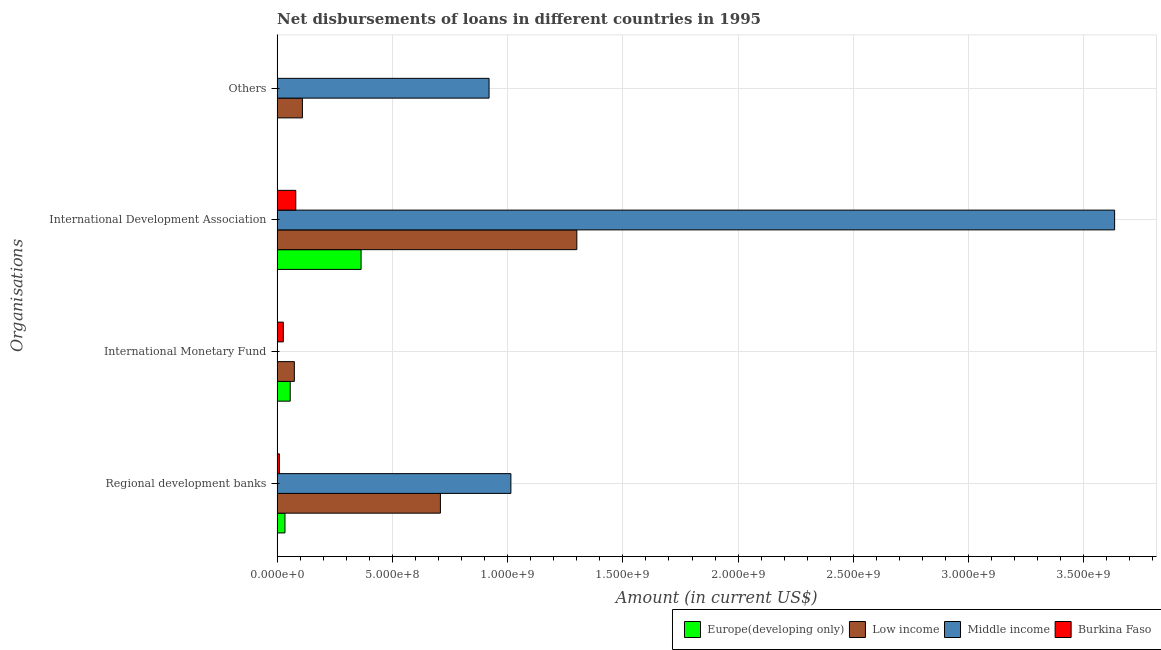How many different coloured bars are there?
Your answer should be very brief. 4. How many groups of bars are there?
Provide a succinct answer. 4. How many bars are there on the 1st tick from the top?
Your answer should be very brief. 2. How many bars are there on the 2nd tick from the bottom?
Provide a short and direct response. 3. What is the label of the 1st group of bars from the top?
Your answer should be very brief. Others. What is the amount of loan disimbursed by regional development banks in Europe(developing only)?
Your answer should be compact. 3.40e+07. Across all countries, what is the maximum amount of loan disimbursed by other organisations?
Keep it short and to the point. 9.20e+08. Across all countries, what is the minimum amount of loan disimbursed by other organisations?
Offer a terse response. 0. What is the total amount of loan disimbursed by international monetary fund in the graph?
Your response must be concise. 1.58e+08. What is the difference between the amount of loan disimbursed by international monetary fund in Europe(developing only) and that in Low income?
Your response must be concise. -1.80e+07. What is the difference between the amount of loan disimbursed by other organisations in Low income and the amount of loan disimbursed by regional development banks in Europe(developing only)?
Your answer should be compact. 7.57e+07. What is the average amount of loan disimbursed by regional development banks per country?
Your response must be concise. 4.42e+08. What is the difference between the amount of loan disimbursed by international development association and amount of loan disimbursed by other organisations in Low income?
Provide a succinct answer. 1.19e+09. In how many countries, is the amount of loan disimbursed by international monetary fund greater than 3200000000 US$?
Provide a short and direct response. 0. What is the ratio of the amount of loan disimbursed by regional development banks in Low income to that in Europe(developing only)?
Offer a terse response. 20.84. Is the amount of loan disimbursed by regional development banks in Burkina Faso less than that in Middle income?
Keep it short and to the point. Yes. Is the difference between the amount of loan disimbursed by regional development banks in Europe(developing only) and Low income greater than the difference between the amount of loan disimbursed by international development association in Europe(developing only) and Low income?
Offer a terse response. Yes. What is the difference between the highest and the second highest amount of loan disimbursed by international development association?
Keep it short and to the point. 2.33e+09. What is the difference between the highest and the lowest amount of loan disimbursed by regional development banks?
Ensure brevity in your answer.  1.00e+09. Is the sum of the amount of loan disimbursed by regional development banks in Burkina Faso and Europe(developing only) greater than the maximum amount of loan disimbursed by international development association across all countries?
Keep it short and to the point. No. Is it the case that in every country, the sum of the amount of loan disimbursed by regional development banks and amount of loan disimbursed by international monetary fund is greater than the amount of loan disimbursed by international development association?
Make the answer very short. No. How many bars are there?
Provide a short and direct response. 13. How many countries are there in the graph?
Provide a short and direct response. 4. What is the difference between two consecutive major ticks on the X-axis?
Provide a short and direct response. 5.00e+08. Does the graph contain any zero values?
Your answer should be very brief. Yes. How many legend labels are there?
Provide a succinct answer. 4. What is the title of the graph?
Make the answer very short. Net disbursements of loans in different countries in 1995. What is the label or title of the Y-axis?
Provide a succinct answer. Organisations. What is the Amount (in current US$) of Europe(developing only) in Regional development banks?
Your answer should be very brief. 3.40e+07. What is the Amount (in current US$) in Low income in Regional development banks?
Your response must be concise. 7.08e+08. What is the Amount (in current US$) of Middle income in Regional development banks?
Make the answer very short. 1.01e+09. What is the Amount (in current US$) in Burkina Faso in Regional development banks?
Offer a terse response. 9.90e+06. What is the Amount (in current US$) in Europe(developing only) in International Monetary Fund?
Provide a succinct answer. 5.67e+07. What is the Amount (in current US$) of Low income in International Monetary Fund?
Ensure brevity in your answer.  7.47e+07. What is the Amount (in current US$) in Burkina Faso in International Monetary Fund?
Your answer should be compact. 2.68e+07. What is the Amount (in current US$) of Europe(developing only) in International Development Association?
Your answer should be very brief. 3.64e+08. What is the Amount (in current US$) of Low income in International Development Association?
Keep it short and to the point. 1.30e+09. What is the Amount (in current US$) of Middle income in International Development Association?
Your answer should be very brief. 3.63e+09. What is the Amount (in current US$) of Burkina Faso in International Development Association?
Provide a short and direct response. 8.10e+07. What is the Amount (in current US$) in Europe(developing only) in Others?
Provide a succinct answer. 0. What is the Amount (in current US$) in Low income in Others?
Provide a succinct answer. 1.10e+08. What is the Amount (in current US$) in Middle income in Others?
Ensure brevity in your answer.  9.20e+08. Across all Organisations, what is the maximum Amount (in current US$) of Europe(developing only)?
Offer a very short reply. 3.64e+08. Across all Organisations, what is the maximum Amount (in current US$) in Low income?
Your answer should be compact. 1.30e+09. Across all Organisations, what is the maximum Amount (in current US$) in Middle income?
Provide a short and direct response. 3.63e+09. Across all Organisations, what is the maximum Amount (in current US$) in Burkina Faso?
Provide a short and direct response. 8.10e+07. Across all Organisations, what is the minimum Amount (in current US$) of Europe(developing only)?
Offer a terse response. 0. Across all Organisations, what is the minimum Amount (in current US$) in Low income?
Your answer should be compact. 7.47e+07. What is the total Amount (in current US$) of Europe(developing only) in the graph?
Your answer should be compact. 4.55e+08. What is the total Amount (in current US$) of Low income in the graph?
Provide a short and direct response. 2.19e+09. What is the total Amount (in current US$) of Middle income in the graph?
Make the answer very short. 5.57e+09. What is the total Amount (in current US$) in Burkina Faso in the graph?
Offer a very short reply. 1.18e+08. What is the difference between the Amount (in current US$) in Europe(developing only) in Regional development banks and that in International Monetary Fund?
Give a very brief answer. -2.27e+07. What is the difference between the Amount (in current US$) of Low income in Regional development banks and that in International Monetary Fund?
Provide a succinct answer. 6.34e+08. What is the difference between the Amount (in current US$) in Burkina Faso in Regional development banks and that in International Monetary Fund?
Provide a succinct answer. -1.69e+07. What is the difference between the Amount (in current US$) of Europe(developing only) in Regional development banks and that in International Development Association?
Ensure brevity in your answer.  -3.30e+08. What is the difference between the Amount (in current US$) in Low income in Regional development banks and that in International Development Association?
Your response must be concise. -5.92e+08. What is the difference between the Amount (in current US$) of Middle income in Regional development banks and that in International Development Association?
Your answer should be very brief. -2.62e+09. What is the difference between the Amount (in current US$) of Burkina Faso in Regional development banks and that in International Development Association?
Make the answer very short. -7.11e+07. What is the difference between the Amount (in current US$) of Low income in Regional development banks and that in Others?
Provide a short and direct response. 5.99e+08. What is the difference between the Amount (in current US$) of Middle income in Regional development banks and that in Others?
Your answer should be compact. 9.47e+07. What is the difference between the Amount (in current US$) of Europe(developing only) in International Monetary Fund and that in International Development Association?
Keep it short and to the point. -3.08e+08. What is the difference between the Amount (in current US$) of Low income in International Monetary Fund and that in International Development Association?
Your answer should be very brief. -1.23e+09. What is the difference between the Amount (in current US$) of Burkina Faso in International Monetary Fund and that in International Development Association?
Provide a short and direct response. -5.41e+07. What is the difference between the Amount (in current US$) in Low income in International Monetary Fund and that in Others?
Offer a terse response. -3.50e+07. What is the difference between the Amount (in current US$) in Low income in International Development Association and that in Others?
Make the answer very short. 1.19e+09. What is the difference between the Amount (in current US$) of Middle income in International Development Association and that in Others?
Your answer should be very brief. 2.71e+09. What is the difference between the Amount (in current US$) in Europe(developing only) in Regional development banks and the Amount (in current US$) in Low income in International Monetary Fund?
Your answer should be very brief. -4.07e+07. What is the difference between the Amount (in current US$) of Europe(developing only) in Regional development banks and the Amount (in current US$) of Burkina Faso in International Monetary Fund?
Provide a succinct answer. 7.18e+06. What is the difference between the Amount (in current US$) in Low income in Regional development banks and the Amount (in current US$) in Burkina Faso in International Monetary Fund?
Keep it short and to the point. 6.82e+08. What is the difference between the Amount (in current US$) of Middle income in Regional development banks and the Amount (in current US$) of Burkina Faso in International Monetary Fund?
Your response must be concise. 9.87e+08. What is the difference between the Amount (in current US$) of Europe(developing only) in Regional development banks and the Amount (in current US$) of Low income in International Development Association?
Your answer should be very brief. -1.27e+09. What is the difference between the Amount (in current US$) of Europe(developing only) in Regional development banks and the Amount (in current US$) of Middle income in International Development Association?
Offer a very short reply. -3.60e+09. What is the difference between the Amount (in current US$) of Europe(developing only) in Regional development banks and the Amount (in current US$) of Burkina Faso in International Development Association?
Offer a terse response. -4.70e+07. What is the difference between the Amount (in current US$) in Low income in Regional development banks and the Amount (in current US$) in Middle income in International Development Association?
Keep it short and to the point. -2.93e+09. What is the difference between the Amount (in current US$) of Low income in Regional development banks and the Amount (in current US$) of Burkina Faso in International Development Association?
Give a very brief answer. 6.27e+08. What is the difference between the Amount (in current US$) in Middle income in Regional development banks and the Amount (in current US$) in Burkina Faso in International Development Association?
Your answer should be very brief. 9.33e+08. What is the difference between the Amount (in current US$) of Europe(developing only) in Regional development banks and the Amount (in current US$) of Low income in Others?
Provide a short and direct response. -7.57e+07. What is the difference between the Amount (in current US$) of Europe(developing only) in Regional development banks and the Amount (in current US$) of Middle income in Others?
Provide a succinct answer. -8.86e+08. What is the difference between the Amount (in current US$) in Low income in Regional development banks and the Amount (in current US$) in Middle income in Others?
Provide a short and direct response. -2.11e+08. What is the difference between the Amount (in current US$) of Europe(developing only) in International Monetary Fund and the Amount (in current US$) of Low income in International Development Association?
Offer a very short reply. -1.24e+09. What is the difference between the Amount (in current US$) in Europe(developing only) in International Monetary Fund and the Amount (in current US$) in Middle income in International Development Association?
Your answer should be compact. -3.58e+09. What is the difference between the Amount (in current US$) in Europe(developing only) in International Monetary Fund and the Amount (in current US$) in Burkina Faso in International Development Association?
Ensure brevity in your answer.  -2.42e+07. What is the difference between the Amount (in current US$) in Low income in International Monetary Fund and the Amount (in current US$) in Middle income in International Development Association?
Ensure brevity in your answer.  -3.56e+09. What is the difference between the Amount (in current US$) of Low income in International Monetary Fund and the Amount (in current US$) of Burkina Faso in International Development Association?
Keep it short and to the point. -6.24e+06. What is the difference between the Amount (in current US$) in Europe(developing only) in International Monetary Fund and the Amount (in current US$) in Low income in Others?
Offer a terse response. -5.30e+07. What is the difference between the Amount (in current US$) of Europe(developing only) in International Monetary Fund and the Amount (in current US$) of Middle income in Others?
Give a very brief answer. -8.63e+08. What is the difference between the Amount (in current US$) in Low income in International Monetary Fund and the Amount (in current US$) in Middle income in Others?
Your answer should be very brief. -8.45e+08. What is the difference between the Amount (in current US$) of Europe(developing only) in International Development Association and the Amount (in current US$) of Low income in Others?
Your answer should be very brief. 2.55e+08. What is the difference between the Amount (in current US$) in Europe(developing only) in International Development Association and the Amount (in current US$) in Middle income in Others?
Your answer should be very brief. -5.55e+08. What is the difference between the Amount (in current US$) of Low income in International Development Association and the Amount (in current US$) of Middle income in Others?
Offer a very short reply. 3.81e+08. What is the average Amount (in current US$) in Europe(developing only) per Organisations?
Provide a succinct answer. 1.14e+08. What is the average Amount (in current US$) in Low income per Organisations?
Keep it short and to the point. 5.48e+08. What is the average Amount (in current US$) in Middle income per Organisations?
Give a very brief answer. 1.39e+09. What is the average Amount (in current US$) in Burkina Faso per Organisations?
Make the answer very short. 2.94e+07. What is the difference between the Amount (in current US$) of Europe(developing only) and Amount (in current US$) of Low income in Regional development banks?
Ensure brevity in your answer.  -6.74e+08. What is the difference between the Amount (in current US$) in Europe(developing only) and Amount (in current US$) in Middle income in Regional development banks?
Your answer should be compact. -9.80e+08. What is the difference between the Amount (in current US$) in Europe(developing only) and Amount (in current US$) in Burkina Faso in Regional development banks?
Your answer should be compact. 2.41e+07. What is the difference between the Amount (in current US$) of Low income and Amount (in current US$) of Middle income in Regional development banks?
Offer a terse response. -3.06e+08. What is the difference between the Amount (in current US$) in Low income and Amount (in current US$) in Burkina Faso in Regional development banks?
Give a very brief answer. 6.99e+08. What is the difference between the Amount (in current US$) of Middle income and Amount (in current US$) of Burkina Faso in Regional development banks?
Your response must be concise. 1.00e+09. What is the difference between the Amount (in current US$) of Europe(developing only) and Amount (in current US$) of Low income in International Monetary Fund?
Ensure brevity in your answer.  -1.80e+07. What is the difference between the Amount (in current US$) of Europe(developing only) and Amount (in current US$) of Burkina Faso in International Monetary Fund?
Provide a short and direct response. 2.99e+07. What is the difference between the Amount (in current US$) of Low income and Amount (in current US$) of Burkina Faso in International Monetary Fund?
Offer a very short reply. 4.79e+07. What is the difference between the Amount (in current US$) in Europe(developing only) and Amount (in current US$) in Low income in International Development Association?
Ensure brevity in your answer.  -9.36e+08. What is the difference between the Amount (in current US$) of Europe(developing only) and Amount (in current US$) of Middle income in International Development Association?
Offer a terse response. -3.27e+09. What is the difference between the Amount (in current US$) of Europe(developing only) and Amount (in current US$) of Burkina Faso in International Development Association?
Provide a short and direct response. 2.83e+08. What is the difference between the Amount (in current US$) in Low income and Amount (in current US$) in Middle income in International Development Association?
Provide a short and direct response. -2.33e+09. What is the difference between the Amount (in current US$) of Low income and Amount (in current US$) of Burkina Faso in International Development Association?
Your answer should be compact. 1.22e+09. What is the difference between the Amount (in current US$) in Middle income and Amount (in current US$) in Burkina Faso in International Development Association?
Provide a short and direct response. 3.55e+09. What is the difference between the Amount (in current US$) of Low income and Amount (in current US$) of Middle income in Others?
Offer a terse response. -8.10e+08. What is the ratio of the Amount (in current US$) of Europe(developing only) in Regional development banks to that in International Monetary Fund?
Ensure brevity in your answer.  0.6. What is the ratio of the Amount (in current US$) of Low income in Regional development banks to that in International Monetary Fund?
Keep it short and to the point. 9.48. What is the ratio of the Amount (in current US$) of Burkina Faso in Regional development banks to that in International Monetary Fund?
Ensure brevity in your answer.  0.37. What is the ratio of the Amount (in current US$) in Europe(developing only) in Regional development banks to that in International Development Association?
Offer a terse response. 0.09. What is the ratio of the Amount (in current US$) in Low income in Regional development banks to that in International Development Association?
Your answer should be compact. 0.54. What is the ratio of the Amount (in current US$) of Middle income in Regional development banks to that in International Development Association?
Provide a short and direct response. 0.28. What is the ratio of the Amount (in current US$) of Burkina Faso in Regional development banks to that in International Development Association?
Offer a very short reply. 0.12. What is the ratio of the Amount (in current US$) in Low income in Regional development banks to that in Others?
Your answer should be very brief. 6.46. What is the ratio of the Amount (in current US$) of Middle income in Regional development banks to that in Others?
Provide a succinct answer. 1.1. What is the ratio of the Amount (in current US$) of Europe(developing only) in International Monetary Fund to that in International Development Association?
Give a very brief answer. 0.16. What is the ratio of the Amount (in current US$) in Low income in International Monetary Fund to that in International Development Association?
Ensure brevity in your answer.  0.06. What is the ratio of the Amount (in current US$) in Burkina Faso in International Monetary Fund to that in International Development Association?
Offer a very short reply. 0.33. What is the ratio of the Amount (in current US$) of Low income in International Monetary Fund to that in Others?
Ensure brevity in your answer.  0.68. What is the ratio of the Amount (in current US$) of Low income in International Development Association to that in Others?
Provide a succinct answer. 11.86. What is the ratio of the Amount (in current US$) of Middle income in International Development Association to that in Others?
Your answer should be compact. 3.95. What is the difference between the highest and the second highest Amount (in current US$) in Europe(developing only)?
Ensure brevity in your answer.  3.08e+08. What is the difference between the highest and the second highest Amount (in current US$) of Low income?
Your answer should be compact. 5.92e+08. What is the difference between the highest and the second highest Amount (in current US$) of Middle income?
Keep it short and to the point. 2.62e+09. What is the difference between the highest and the second highest Amount (in current US$) of Burkina Faso?
Give a very brief answer. 5.41e+07. What is the difference between the highest and the lowest Amount (in current US$) in Europe(developing only)?
Ensure brevity in your answer.  3.64e+08. What is the difference between the highest and the lowest Amount (in current US$) in Low income?
Offer a terse response. 1.23e+09. What is the difference between the highest and the lowest Amount (in current US$) of Middle income?
Offer a very short reply. 3.63e+09. What is the difference between the highest and the lowest Amount (in current US$) of Burkina Faso?
Make the answer very short. 8.10e+07. 